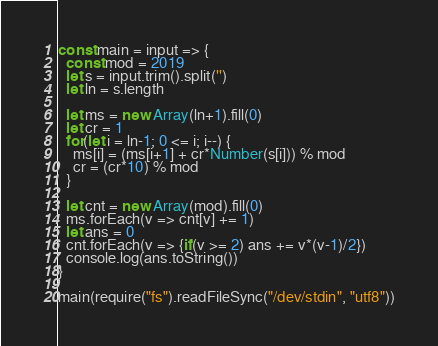<code> <loc_0><loc_0><loc_500><loc_500><_JavaScript_>const main = input => {
  const mod = 2019
  let s = input.trim().split('')
  let ln = s.length
  
  let ms = new Array(ln+1).fill(0)
  let cr = 1
  for(let i = ln-1; 0 <= i; i--) {
    ms[i] = (ms[i+1] + cr*Number(s[i])) % mod
    cr = (cr*10) % mod
  }
  
  let cnt = new Array(mod).fill(0)
  ms.forEach(v => cnt[v] += 1)
  let ans = 0
  cnt.forEach(v => {if(v >= 2) ans += v*(v-1)/2})
  console.log(ans.toString())
}

main(require("fs").readFileSync("/dev/stdin", "utf8"))</code> 